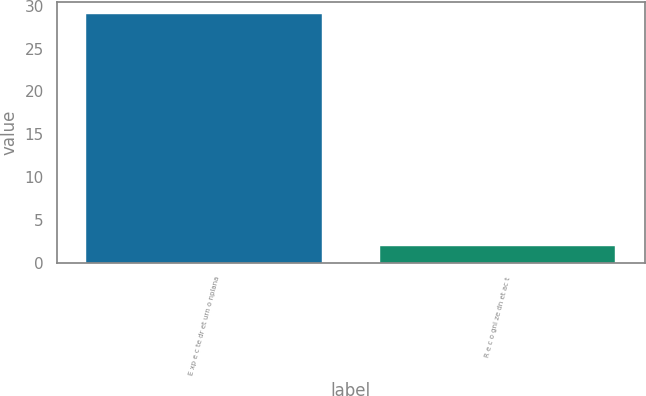Convert chart to OTSL. <chart><loc_0><loc_0><loc_500><loc_500><bar_chart><fcel>E xp e c te dr et urn o nplana<fcel>R e c o gni ze dn et ac t<nl><fcel>29<fcel>2<nl></chart> 